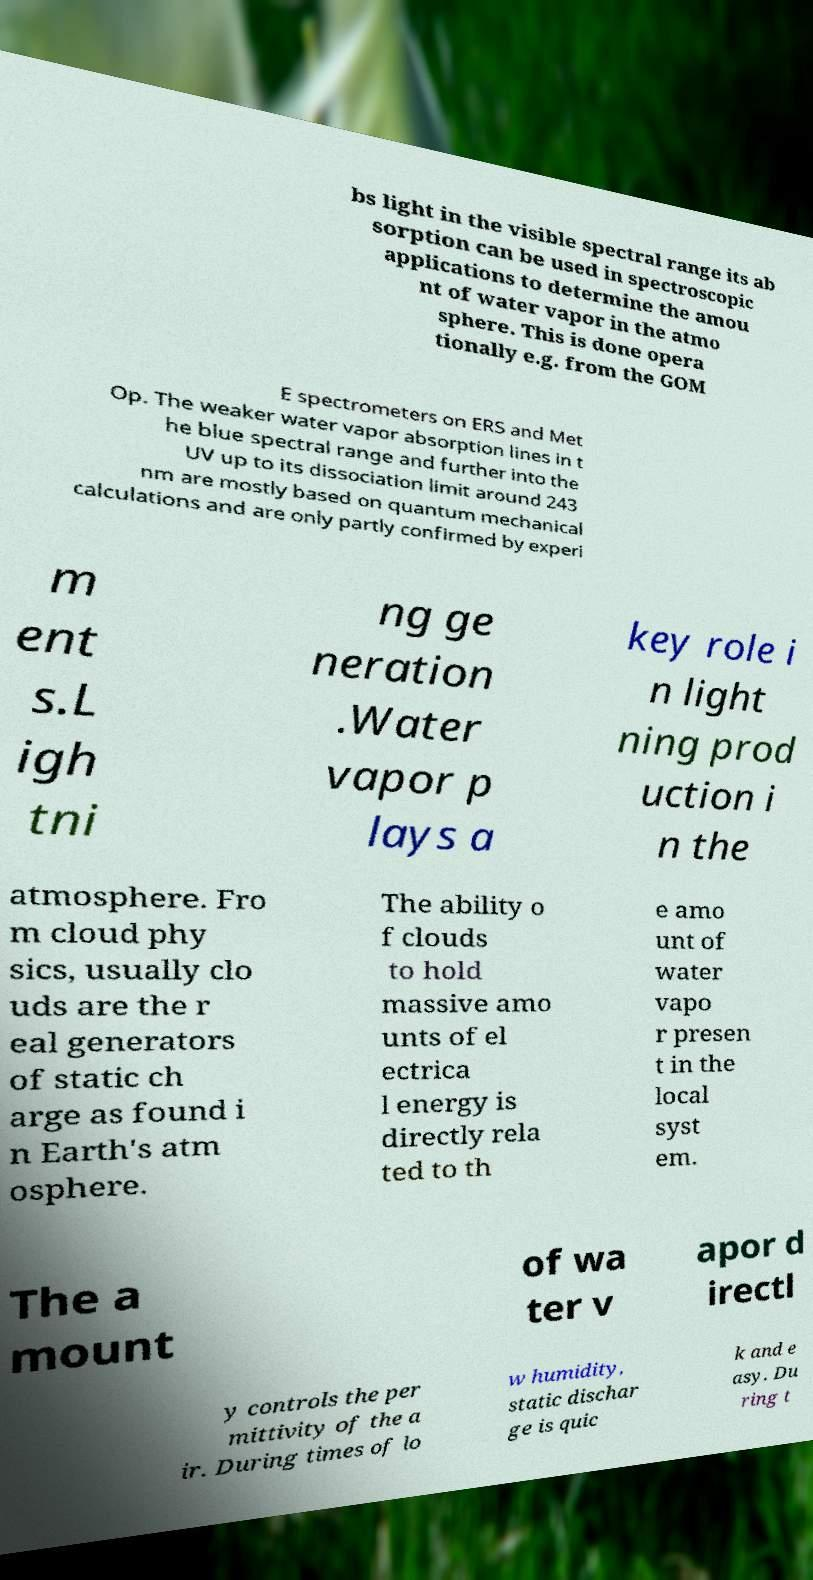What messages or text are displayed in this image? I need them in a readable, typed format. bs light in the visible spectral range its ab sorption can be used in spectroscopic applications to determine the amou nt of water vapor in the atmo sphere. This is done opera tionally e.g. from the GOM E spectrometers on ERS and Met Op. The weaker water vapor absorption lines in t he blue spectral range and further into the UV up to its dissociation limit around 243 nm are mostly based on quantum mechanical calculations and are only partly confirmed by experi m ent s.L igh tni ng ge neration .Water vapor p lays a key role i n light ning prod uction i n the atmosphere. Fro m cloud phy sics, usually clo uds are the r eal generators of static ch arge as found i n Earth's atm osphere. The ability o f clouds to hold massive amo unts of el ectrica l energy is directly rela ted to th e amo unt of water vapo r presen t in the local syst em. The a mount of wa ter v apor d irectl y controls the per mittivity of the a ir. During times of lo w humidity, static dischar ge is quic k and e asy. Du ring t 